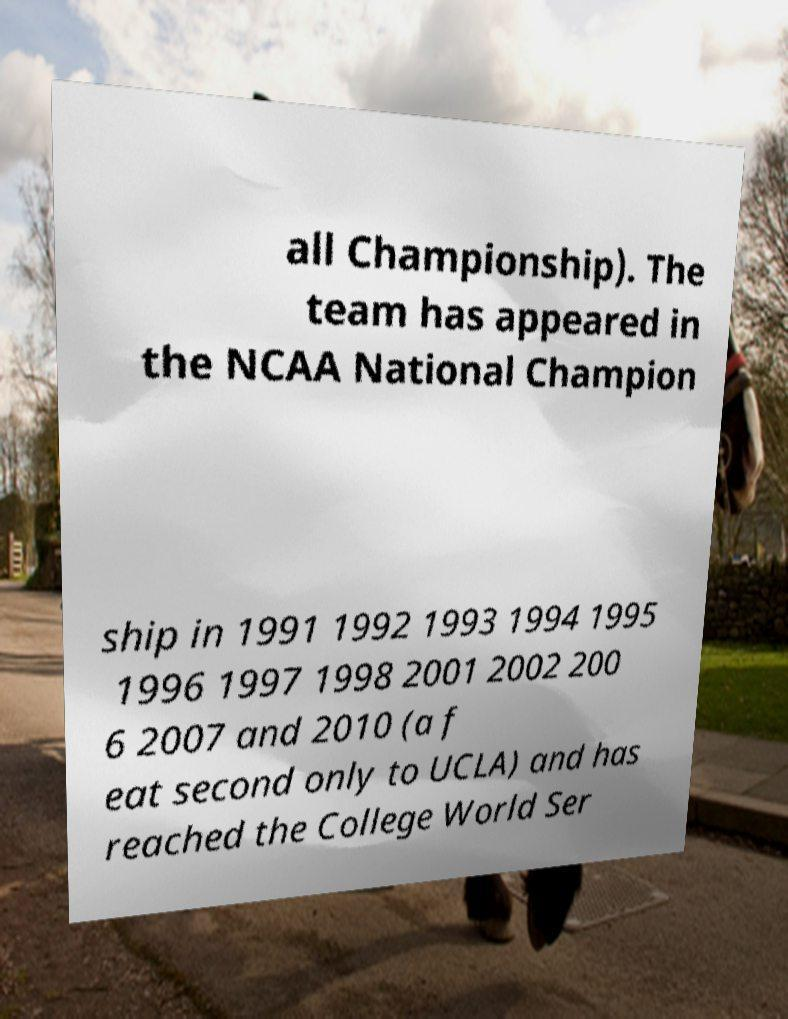What messages or text are displayed in this image? I need them in a readable, typed format. all Championship). The team has appeared in the NCAA National Champion ship in 1991 1992 1993 1994 1995 1996 1997 1998 2001 2002 200 6 2007 and 2010 (a f eat second only to UCLA) and has reached the College World Ser 